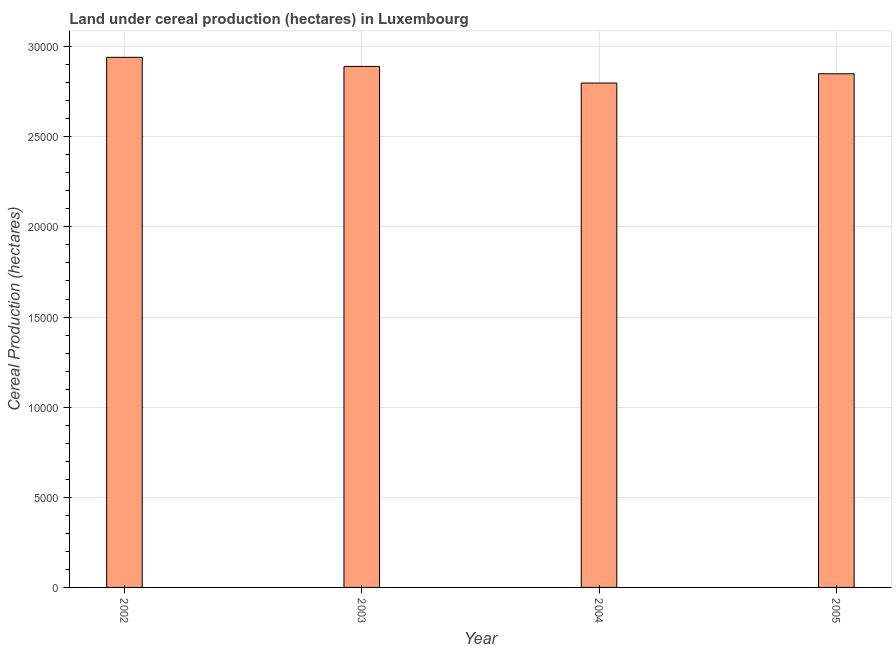What is the title of the graph?
Your answer should be very brief. Land under cereal production (hectares) in Luxembourg. What is the label or title of the X-axis?
Make the answer very short. Year. What is the label or title of the Y-axis?
Your answer should be compact. Cereal Production (hectares). What is the land under cereal production in 2004?
Offer a very short reply. 2.80e+04. Across all years, what is the maximum land under cereal production?
Your answer should be compact. 2.94e+04. Across all years, what is the minimum land under cereal production?
Make the answer very short. 2.80e+04. What is the sum of the land under cereal production?
Make the answer very short. 1.15e+05. What is the difference between the land under cereal production in 2003 and 2005?
Your response must be concise. 407. What is the average land under cereal production per year?
Your response must be concise. 2.87e+04. What is the median land under cereal production?
Offer a very short reply. 2.87e+04. In how many years, is the land under cereal production greater than 23000 hectares?
Offer a terse response. 4. Do a majority of the years between 2002 and 2004 (inclusive) have land under cereal production greater than 29000 hectares?
Provide a short and direct response. No. Is the difference between the land under cereal production in 2002 and 2004 greater than the difference between any two years?
Provide a short and direct response. Yes. What is the difference between the highest and the second highest land under cereal production?
Offer a very short reply. 505. What is the difference between the highest and the lowest land under cereal production?
Give a very brief answer. 1427. Are all the bars in the graph horizontal?
Your answer should be very brief. No. How many years are there in the graph?
Provide a succinct answer. 4. Are the values on the major ticks of Y-axis written in scientific E-notation?
Ensure brevity in your answer.  No. What is the Cereal Production (hectares) of 2002?
Offer a terse response. 2.94e+04. What is the Cereal Production (hectares) of 2003?
Provide a succinct answer. 2.89e+04. What is the Cereal Production (hectares) of 2004?
Provide a short and direct response. 2.80e+04. What is the Cereal Production (hectares) in 2005?
Offer a terse response. 2.85e+04. What is the difference between the Cereal Production (hectares) in 2002 and 2003?
Provide a succinct answer. 505. What is the difference between the Cereal Production (hectares) in 2002 and 2004?
Offer a very short reply. 1427. What is the difference between the Cereal Production (hectares) in 2002 and 2005?
Make the answer very short. 912. What is the difference between the Cereal Production (hectares) in 2003 and 2004?
Make the answer very short. 922. What is the difference between the Cereal Production (hectares) in 2003 and 2005?
Your response must be concise. 407. What is the difference between the Cereal Production (hectares) in 2004 and 2005?
Ensure brevity in your answer.  -515. What is the ratio of the Cereal Production (hectares) in 2002 to that in 2004?
Keep it short and to the point. 1.05. What is the ratio of the Cereal Production (hectares) in 2002 to that in 2005?
Ensure brevity in your answer.  1.03. What is the ratio of the Cereal Production (hectares) in 2003 to that in 2004?
Your response must be concise. 1.03. What is the ratio of the Cereal Production (hectares) in 2003 to that in 2005?
Provide a succinct answer. 1.01. 